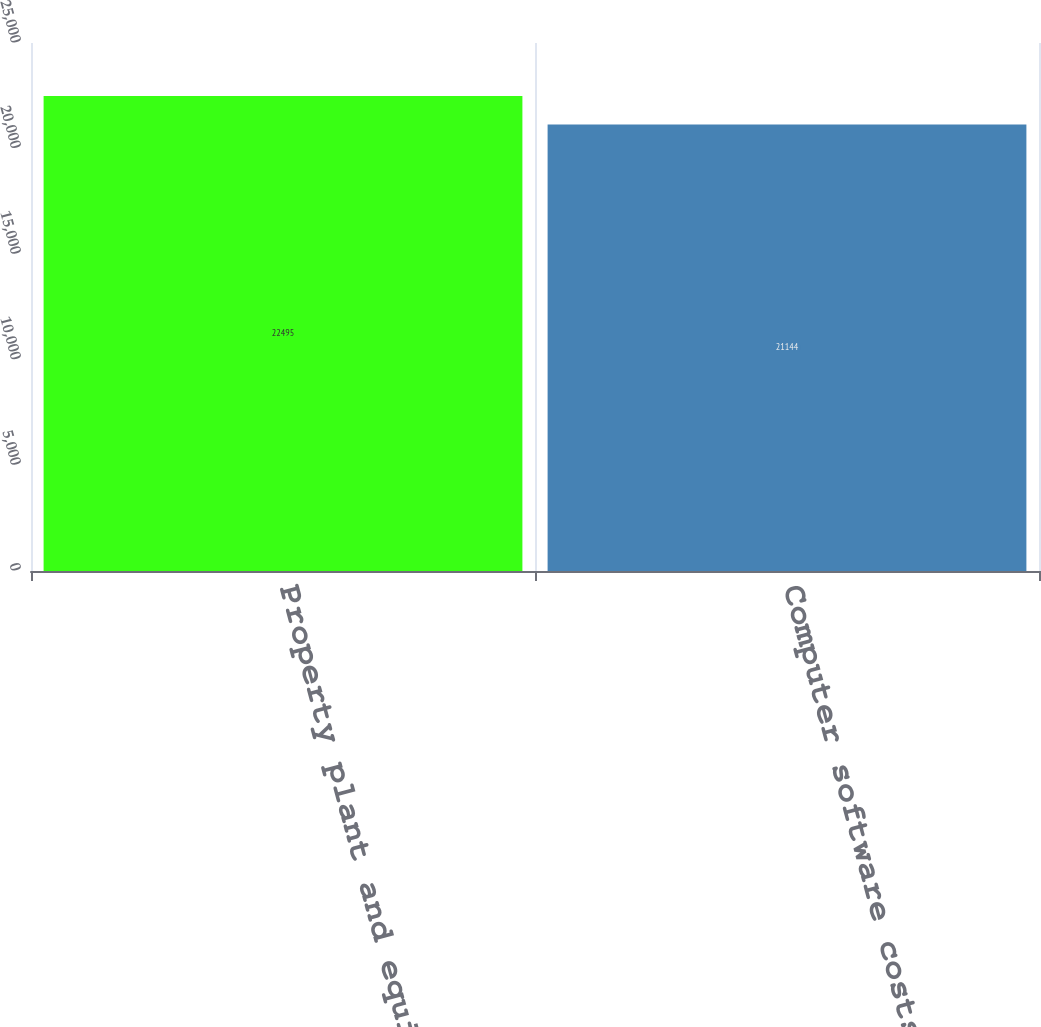<chart> <loc_0><loc_0><loc_500><loc_500><bar_chart><fcel>Property plant and equipment<fcel>Computer software costs<nl><fcel>22495<fcel>21144<nl></chart> 